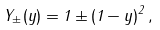<formula> <loc_0><loc_0><loc_500><loc_500>Y _ { \pm } ( y ) = 1 \pm ( 1 - y ) ^ { 2 } \, ,</formula> 